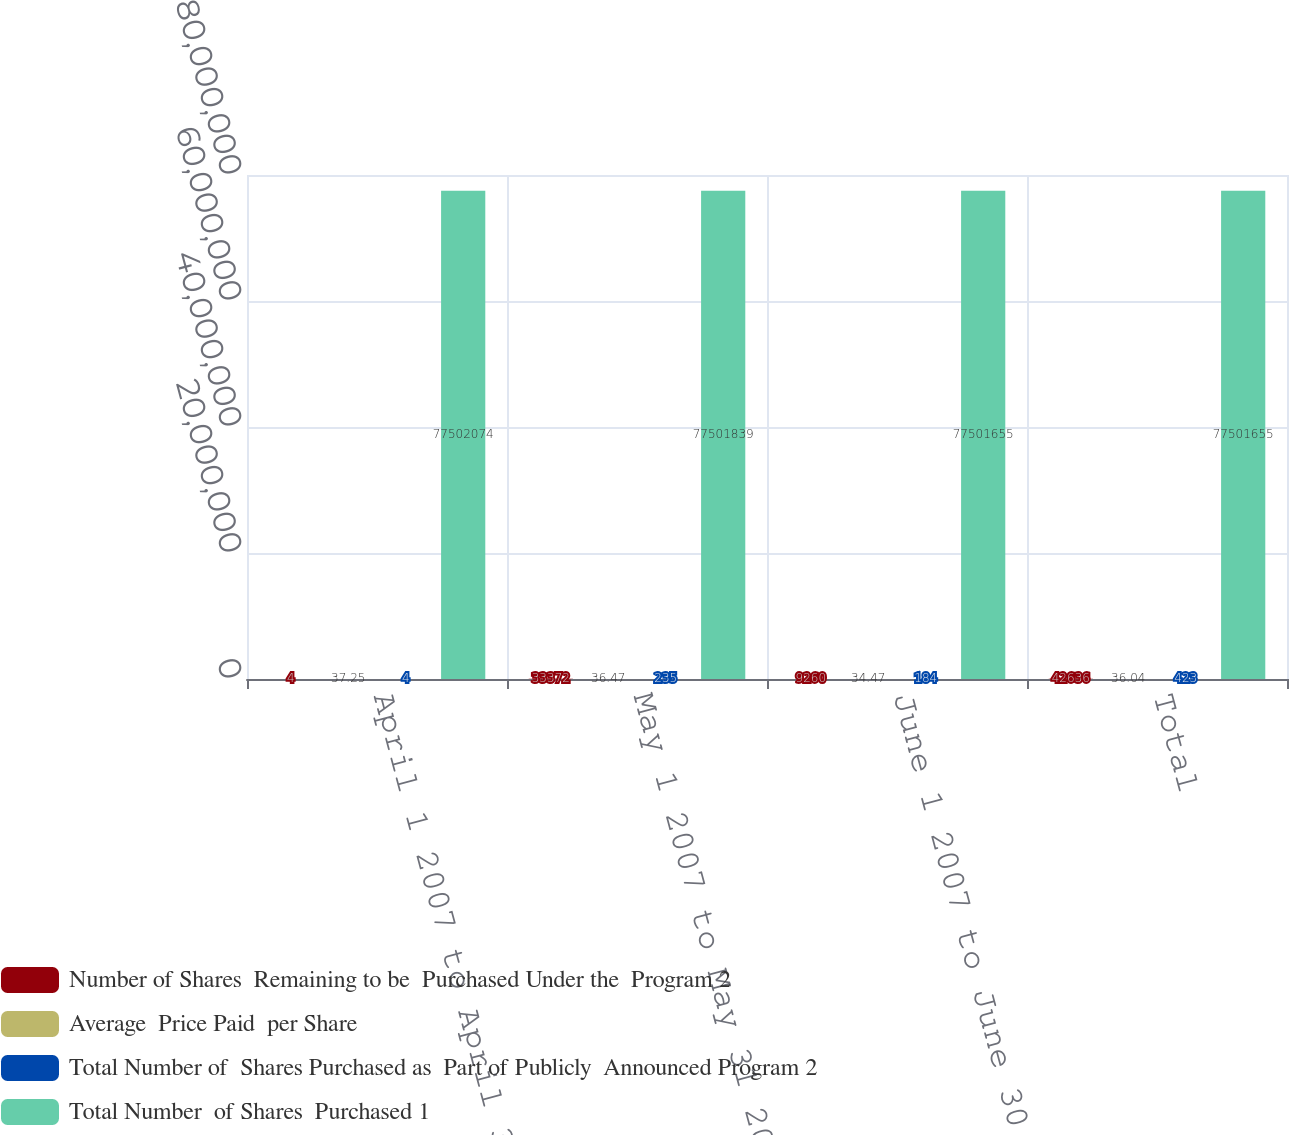Convert chart to OTSL. <chart><loc_0><loc_0><loc_500><loc_500><stacked_bar_chart><ecel><fcel>April 1 2007 to April 30 2007<fcel>May 1 2007 to May 31 2007<fcel>June 1 2007 to June 30 2007<fcel>Total<nl><fcel>Number of Shares  Remaining to be  Purchased Under the  Program 2<fcel>4<fcel>33372<fcel>9260<fcel>42636<nl><fcel>Average  Price Paid  per Share<fcel>37.25<fcel>36.47<fcel>34.47<fcel>36.04<nl><fcel>Total Number of  Shares Purchased as  Part of Publicly  Announced Program 2<fcel>4<fcel>235<fcel>184<fcel>423<nl><fcel>Total Number  of Shares  Purchased 1<fcel>7.75021e+07<fcel>7.75018e+07<fcel>7.75017e+07<fcel>7.75017e+07<nl></chart> 